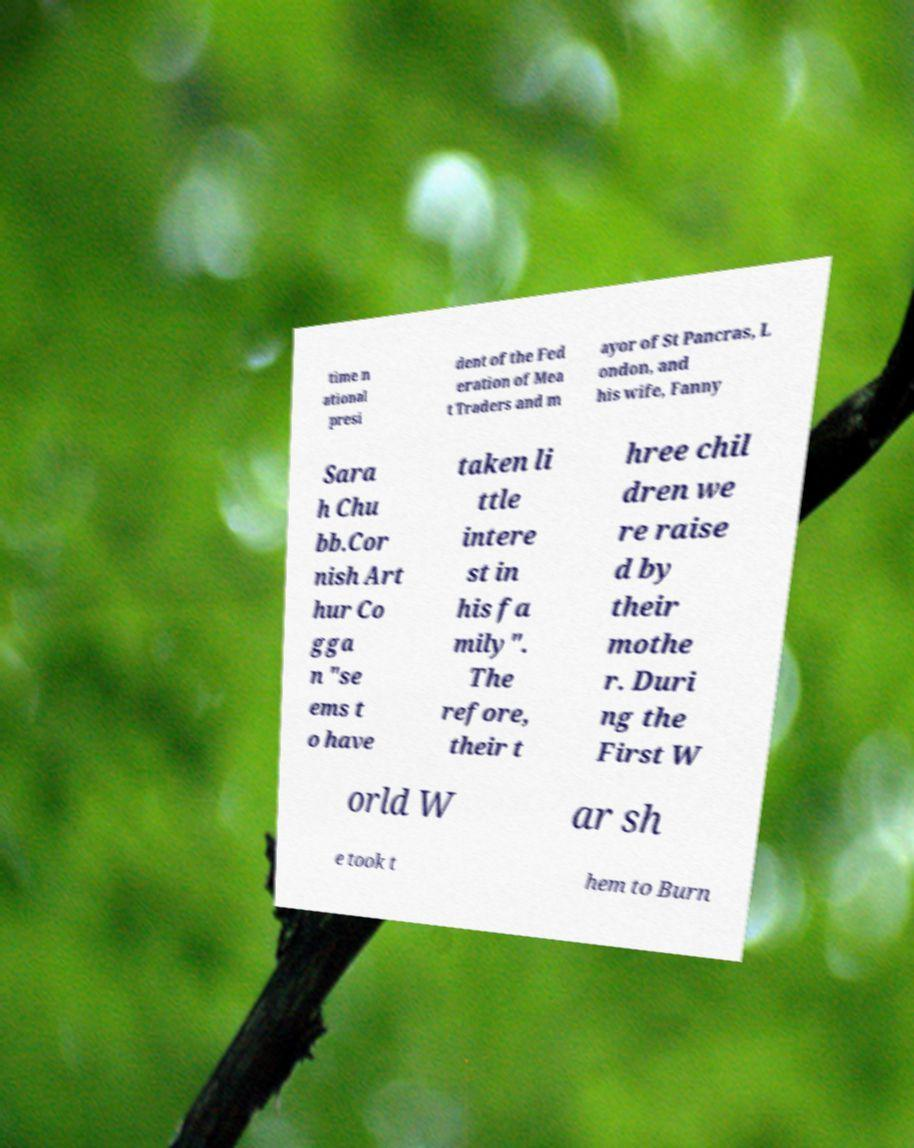Please read and relay the text visible in this image. What does it say? time n ational presi dent of the Fed eration of Mea t Traders and m ayor of St Pancras, L ondon, and his wife, Fanny Sara h Chu bb.Cor nish Art hur Co gga n "se ems t o have taken li ttle intere st in his fa mily". The refore, their t hree chil dren we re raise d by their mothe r. Duri ng the First W orld W ar sh e took t hem to Burn 